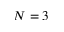Convert formula to latex. <formula><loc_0><loc_0><loc_500><loc_500>N = 3</formula> 